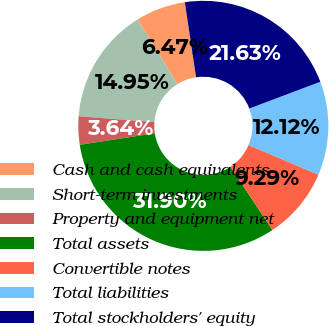Convert chart to OTSL. <chart><loc_0><loc_0><loc_500><loc_500><pie_chart><fcel>Cash and cash equivalents<fcel>Short-term investments<fcel>Property and equipment net<fcel>Total assets<fcel>Convertible notes<fcel>Total liabilities<fcel>Total stockholders' equity<nl><fcel>6.47%<fcel>14.95%<fcel>3.64%<fcel>31.9%<fcel>9.29%<fcel>12.12%<fcel>21.63%<nl></chart> 